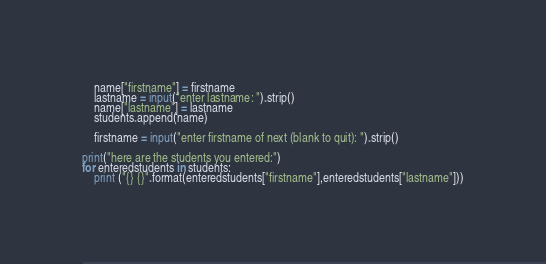Convert code to text. <code><loc_0><loc_0><loc_500><loc_500><_Python_>    name["firstname"] = firstname
    lastname = input("enter lastname: ").strip()
    name["lastname"] = lastname
    students.append(name)

    firstname = input("enter firstname of next (blank to quit): ").strip()

print("here are the students you entered:")
for enteredstudents in students:
    print ("{} {}".format(enteredstudents["firstname"],enteredstudents["lastname"]))</code> 